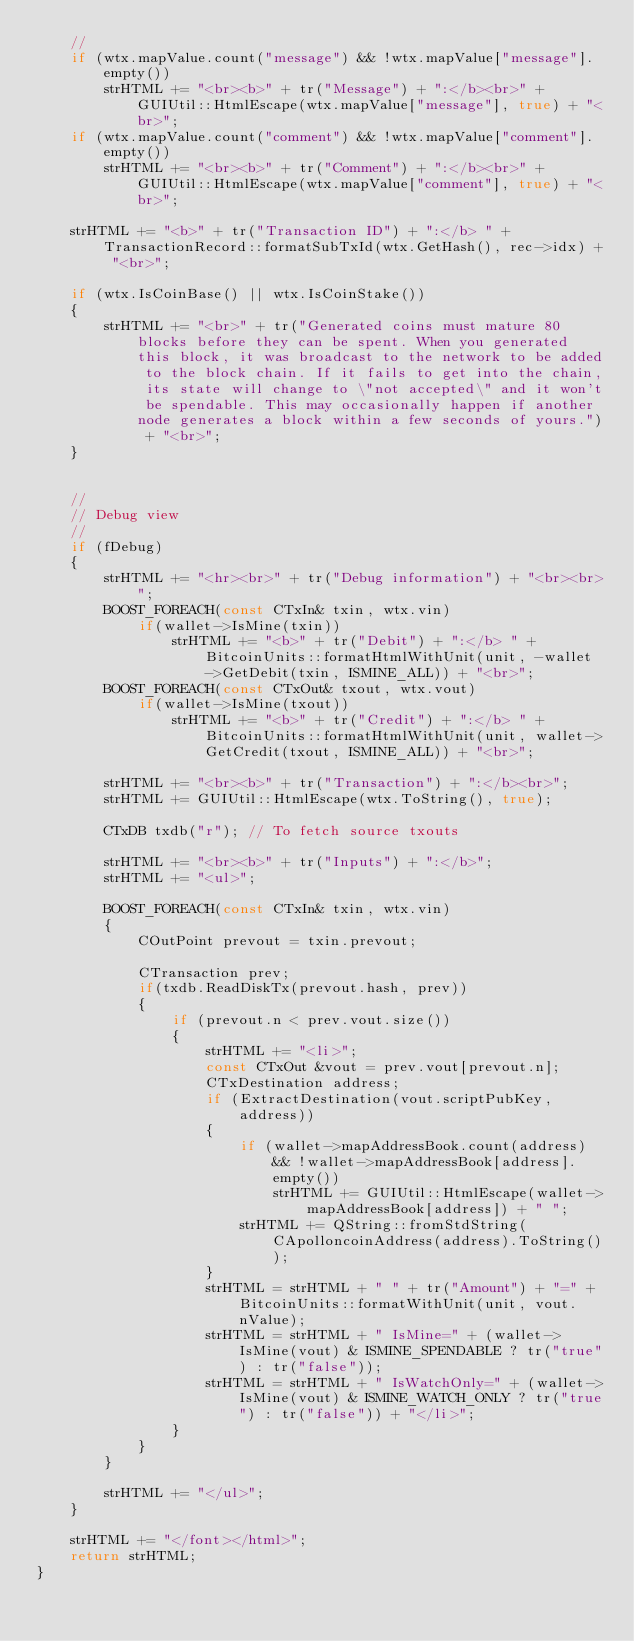Convert code to text. <code><loc_0><loc_0><loc_500><loc_500><_C++_>    //
    if (wtx.mapValue.count("message") && !wtx.mapValue["message"].empty())
        strHTML += "<br><b>" + tr("Message") + ":</b><br>" + GUIUtil::HtmlEscape(wtx.mapValue["message"], true) + "<br>";
    if (wtx.mapValue.count("comment") && !wtx.mapValue["comment"].empty())
        strHTML += "<br><b>" + tr("Comment") + ":</b><br>" + GUIUtil::HtmlEscape(wtx.mapValue["comment"], true) + "<br>";

    strHTML += "<b>" + tr("Transaction ID") + ":</b> " + TransactionRecord::formatSubTxId(wtx.GetHash(), rec->idx) + "<br>";

    if (wtx.IsCoinBase() || wtx.IsCoinStake())
    {
        strHTML += "<br>" + tr("Generated coins must mature 80 blocks before they can be spent. When you generated this block, it was broadcast to the network to be added to the block chain. If it fails to get into the chain, its state will change to \"not accepted\" and it won't be spendable. This may occasionally happen if another node generates a block within a few seconds of yours.") + "<br>";
    }


    //
    // Debug view
    //
    if (fDebug)
    {
        strHTML += "<hr><br>" + tr("Debug information") + "<br><br>";
        BOOST_FOREACH(const CTxIn& txin, wtx.vin)
            if(wallet->IsMine(txin))
                strHTML += "<b>" + tr("Debit") + ":</b> " + BitcoinUnits::formatHtmlWithUnit(unit, -wallet->GetDebit(txin, ISMINE_ALL)) + "<br>";
        BOOST_FOREACH(const CTxOut& txout, wtx.vout)
            if(wallet->IsMine(txout))
                strHTML += "<b>" + tr("Credit") + ":</b> " + BitcoinUnits::formatHtmlWithUnit(unit, wallet->GetCredit(txout, ISMINE_ALL)) + "<br>";

        strHTML += "<br><b>" + tr("Transaction") + ":</b><br>";
        strHTML += GUIUtil::HtmlEscape(wtx.ToString(), true);

        CTxDB txdb("r"); // To fetch source txouts

        strHTML += "<br><b>" + tr("Inputs") + ":</b>";
        strHTML += "<ul>";

        BOOST_FOREACH(const CTxIn& txin, wtx.vin)
        {
            COutPoint prevout = txin.prevout;

            CTransaction prev;
            if(txdb.ReadDiskTx(prevout.hash, prev))
            {
                if (prevout.n < prev.vout.size())
                {
                    strHTML += "<li>";
                    const CTxOut &vout = prev.vout[prevout.n];
                    CTxDestination address;
                    if (ExtractDestination(vout.scriptPubKey, address))
                    {
                        if (wallet->mapAddressBook.count(address) && !wallet->mapAddressBook[address].empty())
                            strHTML += GUIUtil::HtmlEscape(wallet->mapAddressBook[address]) + " ";
                        strHTML += QString::fromStdString(CApolloncoinAddress(address).ToString());
                    }
                    strHTML = strHTML + " " + tr("Amount") + "=" + BitcoinUnits::formatWithUnit(unit, vout.nValue);
                    strHTML = strHTML + " IsMine=" + (wallet->IsMine(vout) & ISMINE_SPENDABLE ? tr("true") : tr("false"));
                    strHTML = strHTML + " IsWatchOnly=" + (wallet->IsMine(vout) & ISMINE_WATCH_ONLY ? tr("true") : tr("false")) + "</li>";
                }
            }
        }

        strHTML += "</ul>";
    }

    strHTML += "</font></html>";
    return strHTML;
}
</code> 